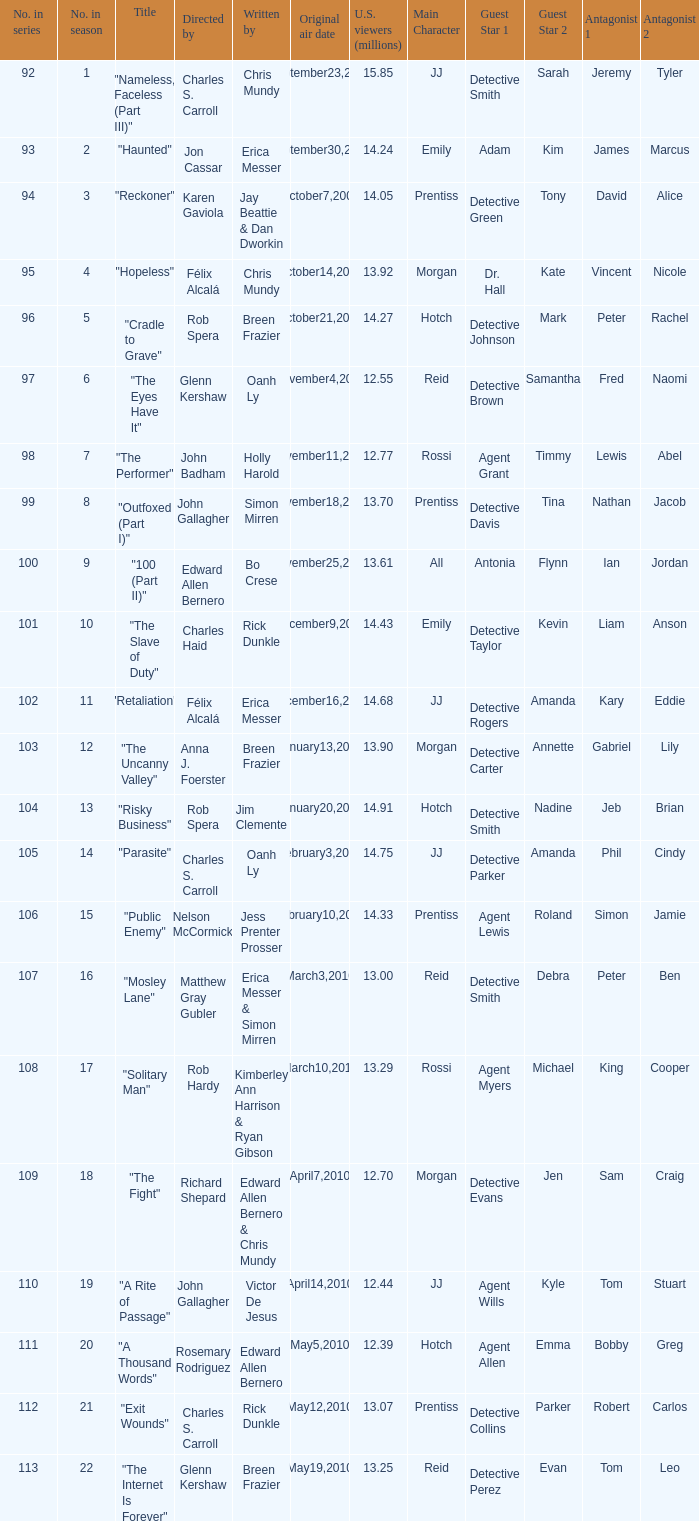What was the original air date for the episode with 13.92 million us viewers? October14,2009. 